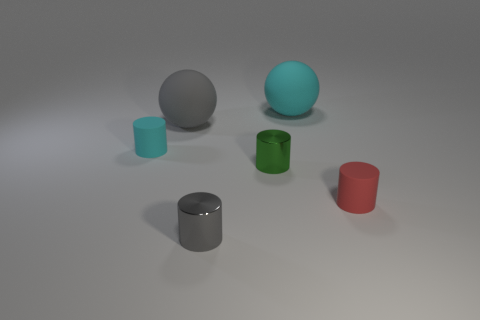There is a rubber object that is on the left side of the gray matte thing; is its size the same as the gray ball?
Your response must be concise. No. What number of other cylinders have the same material as the tiny cyan cylinder?
Your answer should be compact. 1. There is a gray object behind the cyan matte thing to the left of the gray thing in front of the small cyan rubber thing; what is it made of?
Give a very brief answer. Rubber. What color is the small matte cylinder that is to the left of the tiny metallic object in front of the red rubber cylinder?
Ensure brevity in your answer.  Cyan. There is a rubber thing that is the same size as the cyan rubber cylinder; what is its color?
Keep it short and to the point. Red. How many tiny objects are either gray matte things or brown rubber cylinders?
Make the answer very short. 0. Is the number of big objects that are left of the big gray matte object greater than the number of cyan matte objects right of the green cylinder?
Your answer should be very brief. No. How many other objects are the same size as the gray metallic object?
Offer a terse response. 3. Is the large object that is in front of the large cyan object made of the same material as the cyan cylinder?
Your answer should be compact. Yes. What number of other objects are the same shape as the red matte thing?
Keep it short and to the point. 3. 